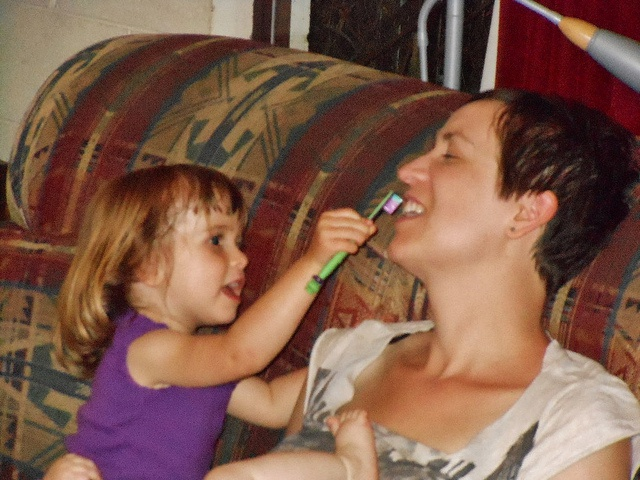Describe the objects in this image and their specific colors. I can see couch in gray, maroon, and black tones, people in gray, tan, black, and salmon tones, people in gray, purple, tan, salmon, and brown tones, and toothbrush in gray, olive, and lightgreen tones in this image. 